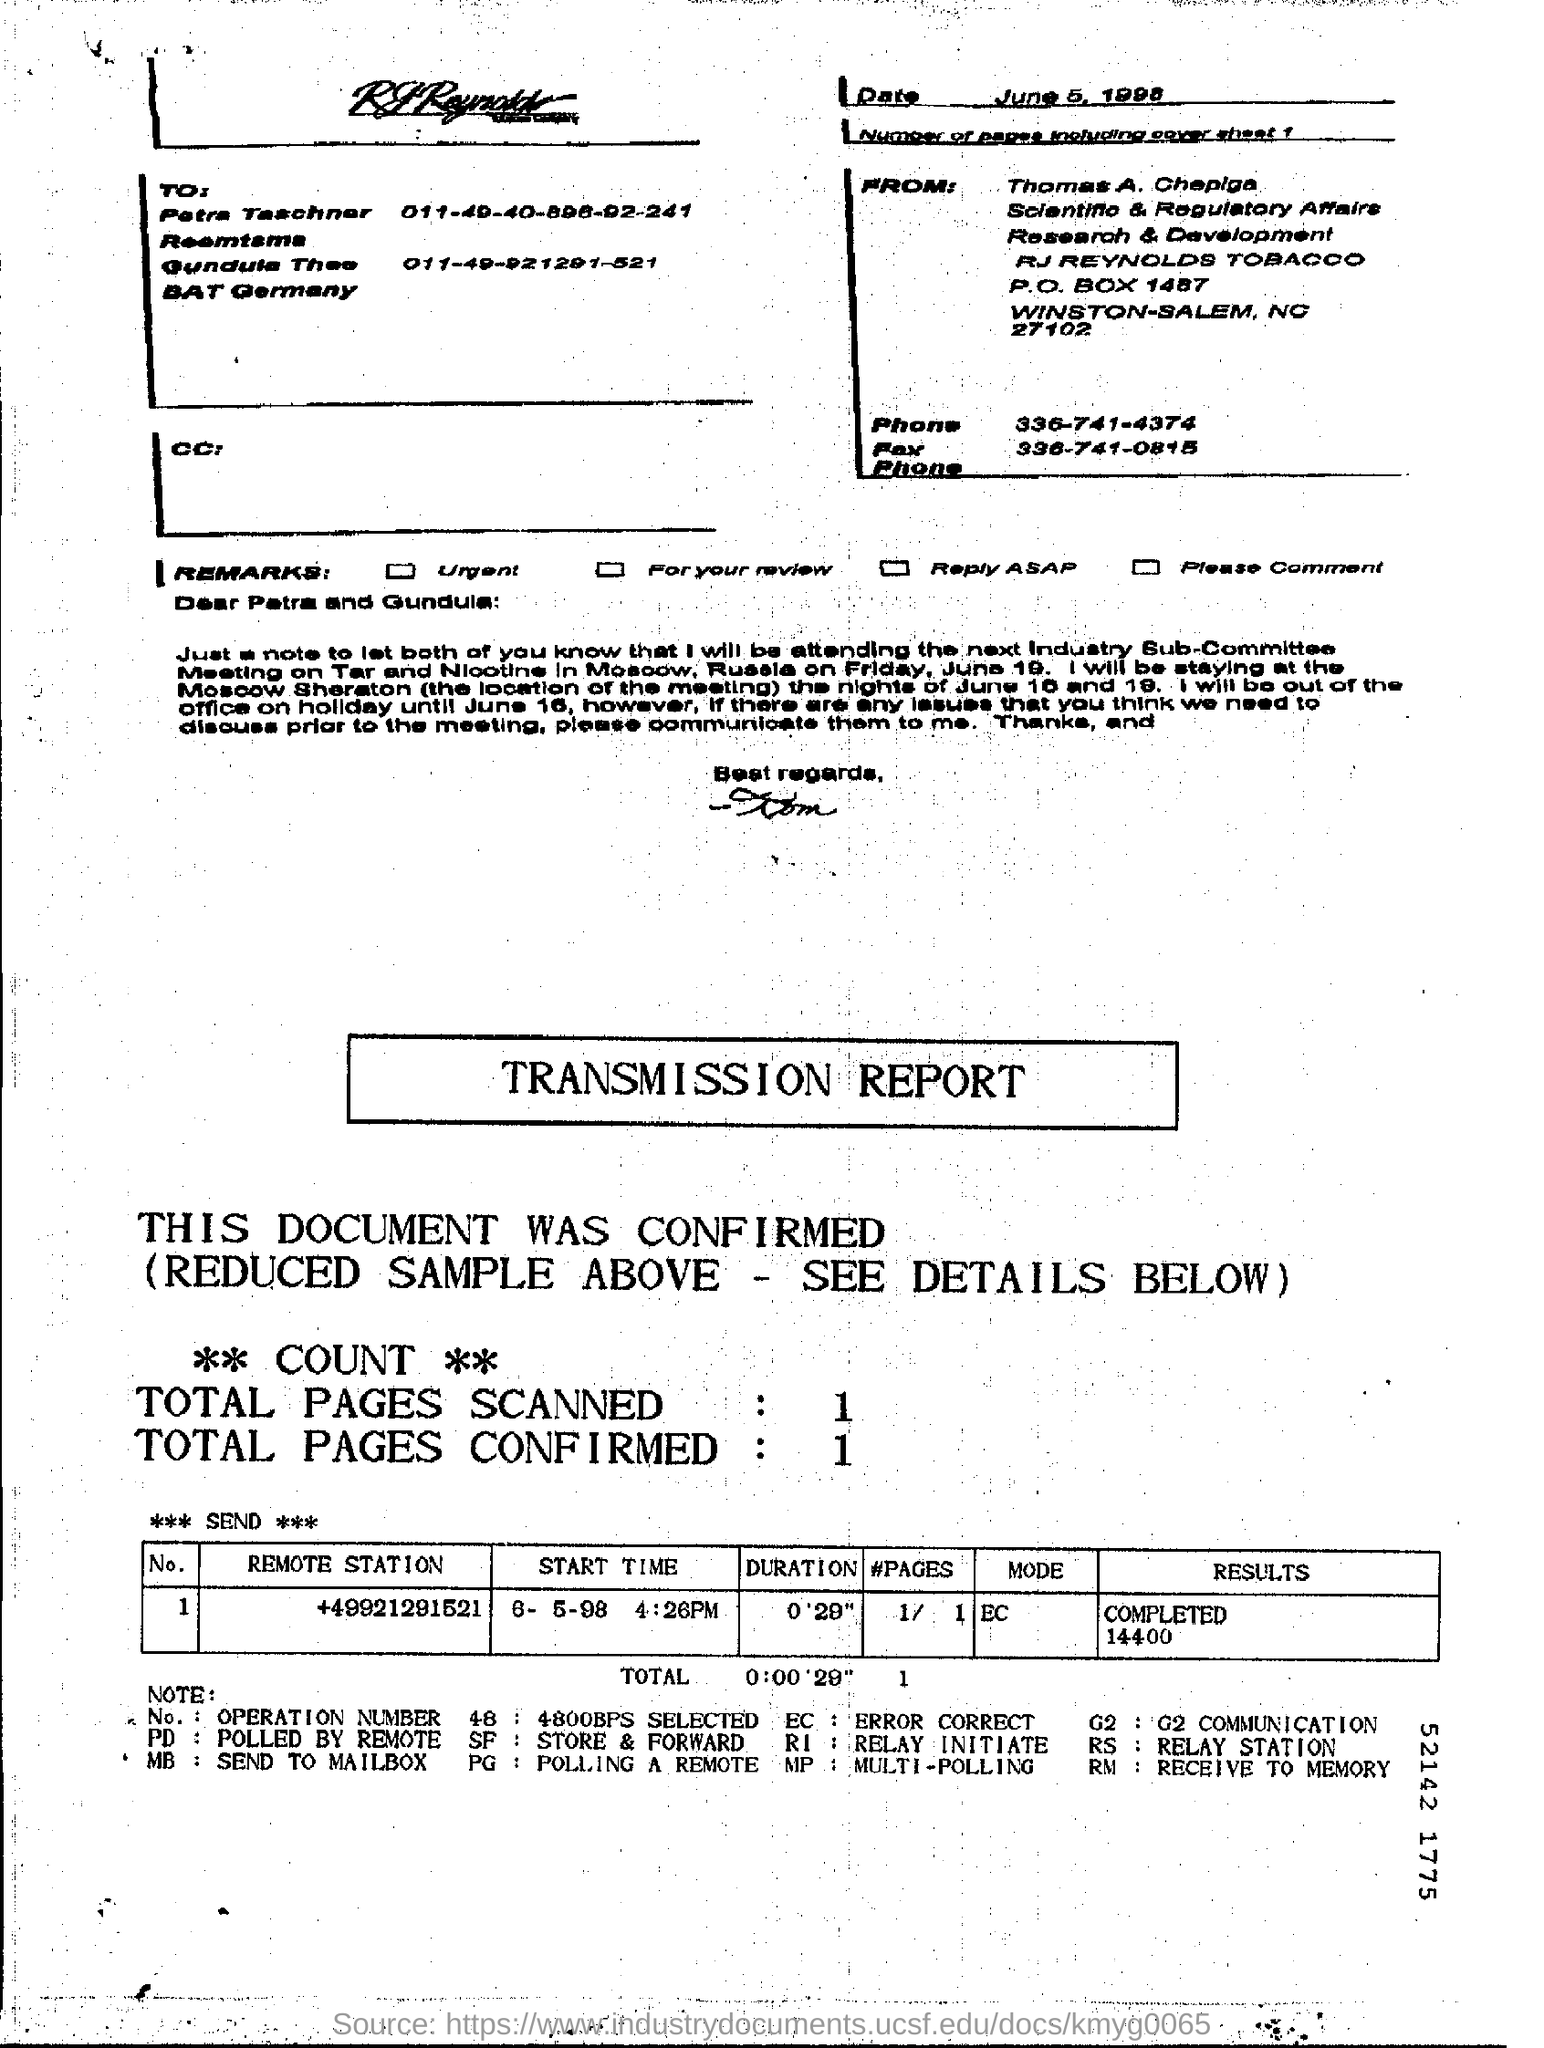Indicate a few pertinent items in this graphic. A total of 1 page was confirmed. The remote station number is +49921291521...," is a specific sequence of numbers that can be used to identify a remote station. There is only one page including the cover sheet. The mode is a measure of central tendency that is used to identify the most frequently occurring value in a data set. The mode is often used when the data set does not have a clear median or mean, and it is important to note that a data set can have more than one mode. 